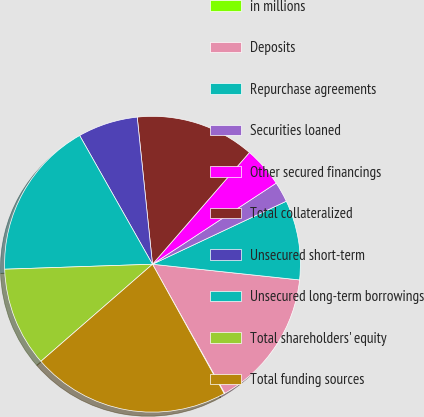Convert chart to OTSL. <chart><loc_0><loc_0><loc_500><loc_500><pie_chart><fcel>in millions<fcel>Deposits<fcel>Repurchase agreements<fcel>Securities loaned<fcel>Other secured financings<fcel>Total collateralized<fcel>Unsecured short-term<fcel>Unsecured long-term borrowings<fcel>Total shareholders' equity<fcel>Total funding sources<nl><fcel>0.07%<fcel>15.18%<fcel>8.7%<fcel>2.23%<fcel>4.39%<fcel>13.02%<fcel>6.55%<fcel>17.34%<fcel>10.86%<fcel>21.66%<nl></chart> 